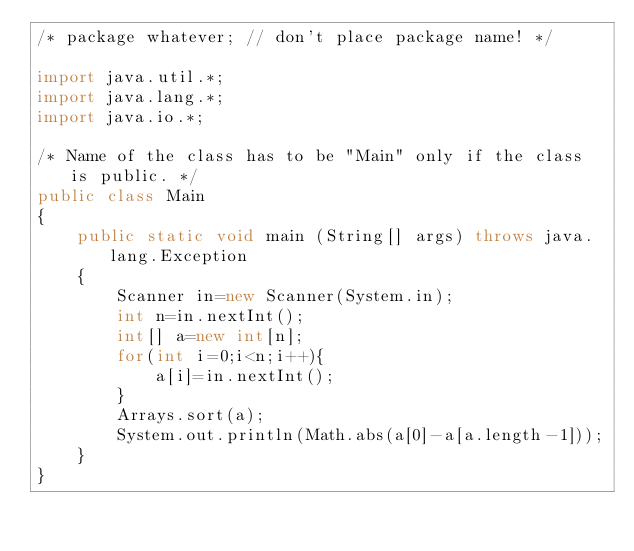<code> <loc_0><loc_0><loc_500><loc_500><_Java_>/* package whatever; // don't place package name! */

import java.util.*;
import java.lang.*;
import java.io.*;

/* Name of the class has to be "Main" only if the class is public. */
public class Main
{
	public static void main (String[] args) throws java.lang.Exception
	{
		Scanner in=new Scanner(System.in);
		int n=in.nextInt();
		int[] a=new int[n];
		for(int i=0;i<n;i++){
			a[i]=in.nextInt();
		}
		Arrays.sort(a);
		System.out.println(Math.abs(a[0]-a[a.length-1]));
	}
}</code> 